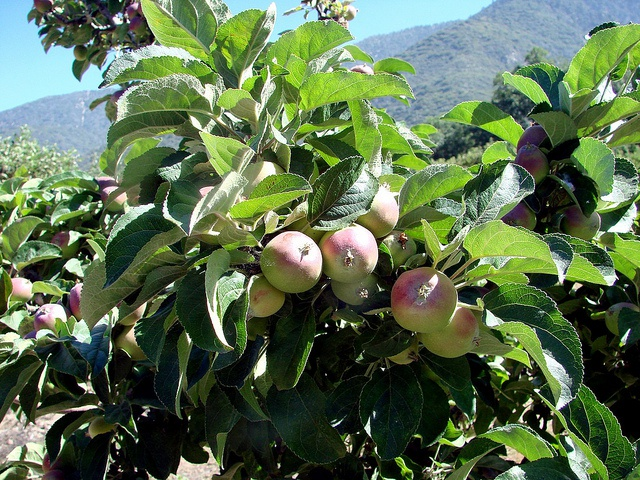Describe the objects in this image and their specific colors. I can see apple in lightblue, olive, gray, and maroon tones, apple in lightblue, olive, white, lightpink, and gray tones, apple in lightblue, white, olive, brown, and gray tones, apple in lightblue, white, olive, and tan tones, and apple in lightblue, olive, gray, and black tones in this image. 